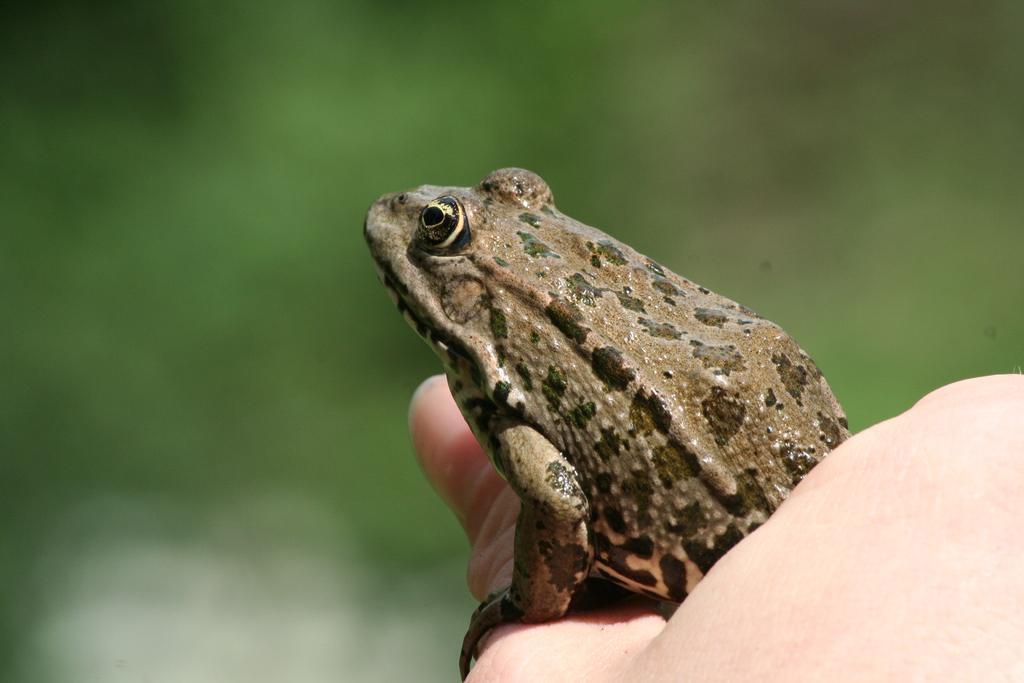In one or two sentences, can you explain what this image depicts? In this picture we can see a frog and human hand. 